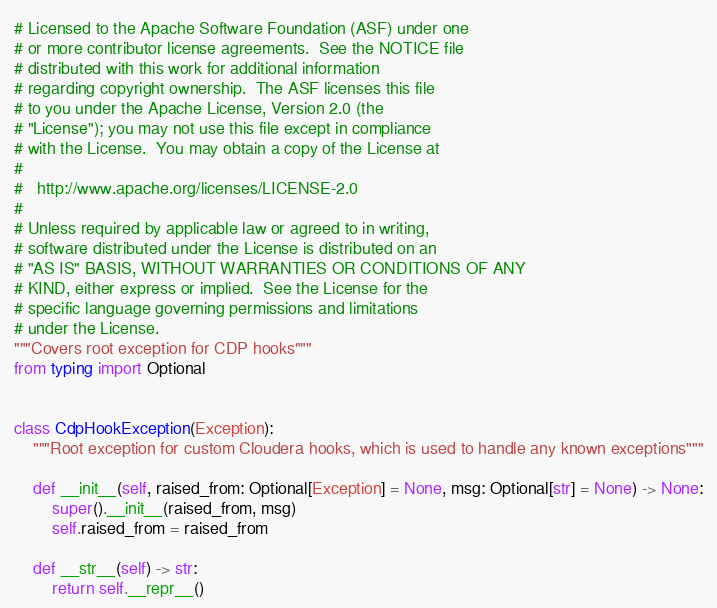<code> <loc_0><loc_0><loc_500><loc_500><_Python_># Licensed to the Apache Software Foundation (ASF) under one
# or more contributor license agreements.  See the NOTICE file
# distributed with this work for additional information
# regarding copyright ownership.  The ASF licenses this file
# to you under the Apache License, Version 2.0 (the
# "License"); you may not use this file except in compliance
# with the License.  You may obtain a copy of the License at
#
#   http://www.apache.org/licenses/LICENSE-2.0
#
# Unless required by applicable law or agreed to in writing,
# software distributed under the License is distributed on an
# "AS IS" BASIS, WITHOUT WARRANTIES OR CONDITIONS OF ANY
# KIND, either express or implied.  See the License for the
# specific language governing permissions and limitations
# under the License.
"""Covers root exception for CDP hooks"""
from typing import Optional


class CdpHookException(Exception):
    """Root exception for custom Cloudera hooks, which is used to handle any known exceptions"""

    def __init__(self, raised_from: Optional[Exception] = None, msg: Optional[str] = None) -> None:
        super().__init__(raised_from, msg)
        self.raised_from = raised_from

    def __str__(self) -> str:
        return self.__repr__()
</code> 